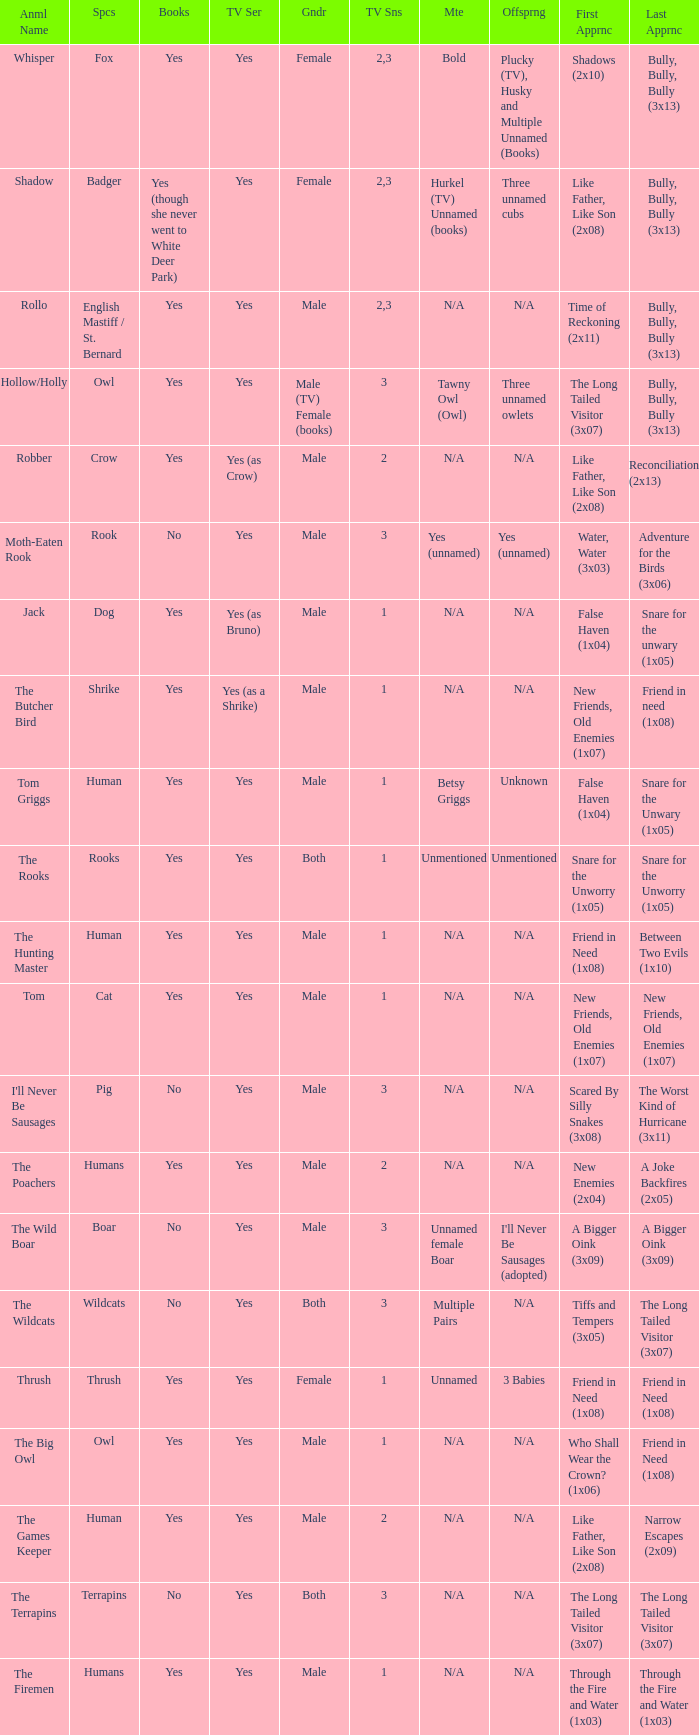What show has a boar? Yes. 